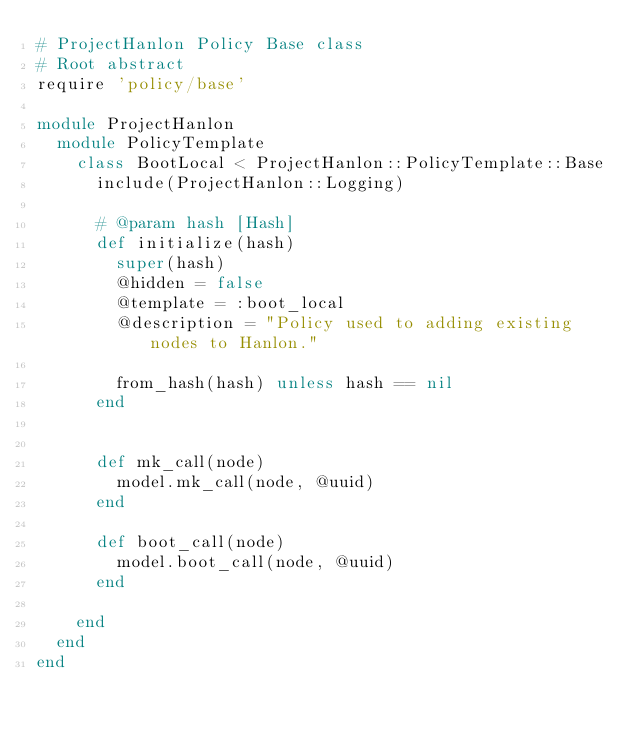<code> <loc_0><loc_0><loc_500><loc_500><_Ruby_># ProjectHanlon Policy Base class
# Root abstract
require 'policy/base'

module ProjectHanlon
  module PolicyTemplate
    class BootLocal < ProjectHanlon::PolicyTemplate::Base
      include(ProjectHanlon::Logging)

      # @param hash [Hash]
      def initialize(hash)
        super(hash)
        @hidden = false
        @template = :boot_local
        @description = "Policy used to adding existing nodes to Hanlon."

        from_hash(hash) unless hash == nil
      end


      def mk_call(node)
        model.mk_call(node, @uuid)
      end

      def boot_call(node)
        model.boot_call(node, @uuid)
      end

    end
  end
end
</code> 